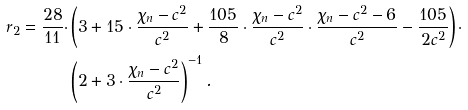<formula> <loc_0><loc_0><loc_500><loc_500>r _ { 2 } = \frac { 2 8 } { 1 1 } \cdot & \left ( 3 + 1 5 \cdot \frac { \chi _ { n } - c ^ { 2 } } { c ^ { 2 } } + \frac { 1 0 5 } { 8 } \cdot \frac { \chi _ { n } - c ^ { 2 } } { c ^ { 2 } } \cdot \frac { \chi _ { n } - c ^ { 2 } - 6 } { c ^ { 2 } } - \frac { 1 0 5 } { 2 c ^ { 2 } } \right ) \cdot \\ & \left ( 2 + 3 \cdot \frac { \chi _ { n } - c ^ { 2 } } { c ^ { 2 } } \right ) ^ { - 1 } .</formula> 